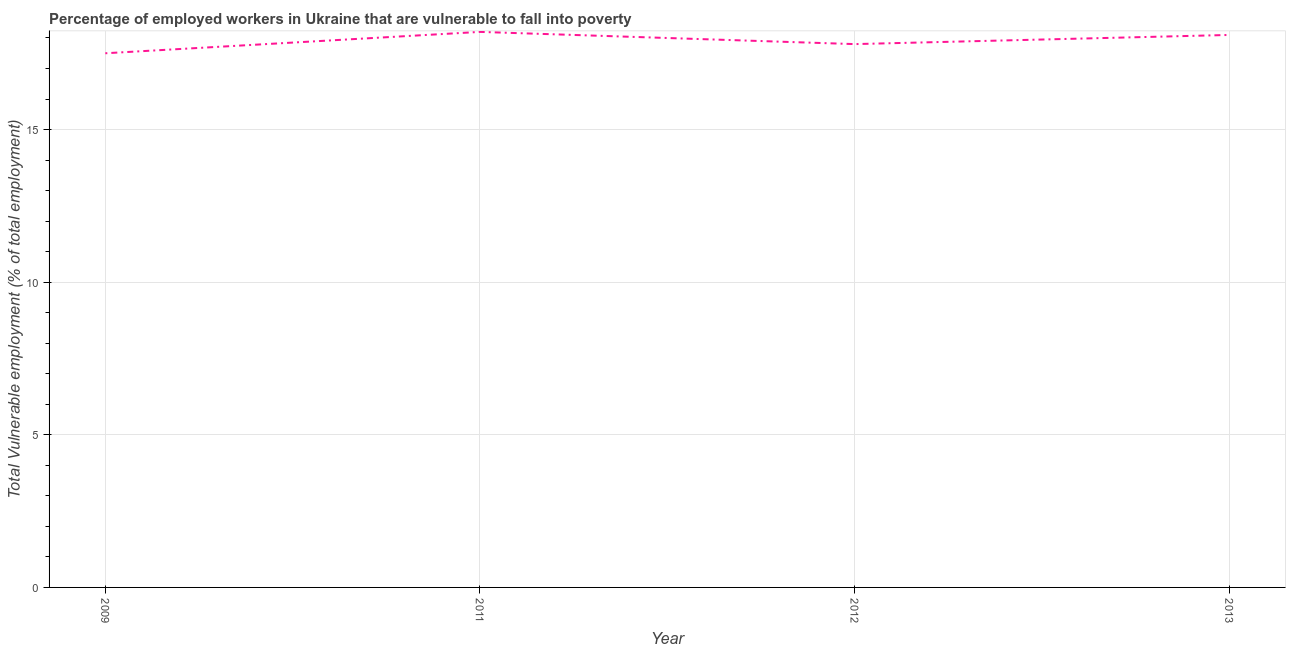What is the total vulnerable employment in 2011?
Keep it short and to the point. 18.2. Across all years, what is the maximum total vulnerable employment?
Your answer should be very brief. 18.2. Across all years, what is the minimum total vulnerable employment?
Your response must be concise. 17.5. In which year was the total vulnerable employment maximum?
Keep it short and to the point. 2011. What is the sum of the total vulnerable employment?
Give a very brief answer. 71.6. What is the difference between the total vulnerable employment in 2012 and 2013?
Ensure brevity in your answer.  -0.3. What is the average total vulnerable employment per year?
Give a very brief answer. 17.9. What is the median total vulnerable employment?
Give a very brief answer. 17.95. Do a majority of the years between 2013 and 2009 (inclusive) have total vulnerable employment greater than 6 %?
Keep it short and to the point. Yes. What is the ratio of the total vulnerable employment in 2009 to that in 2011?
Provide a short and direct response. 0.96. Is the difference between the total vulnerable employment in 2009 and 2011 greater than the difference between any two years?
Your response must be concise. Yes. What is the difference between the highest and the second highest total vulnerable employment?
Offer a terse response. 0.1. What is the difference between the highest and the lowest total vulnerable employment?
Provide a succinct answer. 0.7. In how many years, is the total vulnerable employment greater than the average total vulnerable employment taken over all years?
Provide a succinct answer. 2. How many years are there in the graph?
Your answer should be very brief. 4. What is the difference between two consecutive major ticks on the Y-axis?
Provide a short and direct response. 5. Does the graph contain grids?
Keep it short and to the point. Yes. What is the title of the graph?
Provide a short and direct response. Percentage of employed workers in Ukraine that are vulnerable to fall into poverty. What is the label or title of the Y-axis?
Provide a succinct answer. Total Vulnerable employment (% of total employment). What is the Total Vulnerable employment (% of total employment) of 2009?
Offer a terse response. 17.5. What is the Total Vulnerable employment (% of total employment) in 2011?
Offer a terse response. 18.2. What is the Total Vulnerable employment (% of total employment) of 2012?
Your answer should be compact. 17.8. What is the Total Vulnerable employment (% of total employment) in 2013?
Keep it short and to the point. 18.1. What is the difference between the Total Vulnerable employment (% of total employment) in 2009 and 2013?
Ensure brevity in your answer.  -0.6. What is the difference between the Total Vulnerable employment (% of total employment) in 2011 and 2012?
Keep it short and to the point. 0.4. What is the difference between the Total Vulnerable employment (% of total employment) in 2011 and 2013?
Offer a terse response. 0.1. What is the ratio of the Total Vulnerable employment (% of total employment) in 2009 to that in 2011?
Provide a short and direct response. 0.96. What is the ratio of the Total Vulnerable employment (% of total employment) in 2009 to that in 2012?
Ensure brevity in your answer.  0.98. What is the ratio of the Total Vulnerable employment (% of total employment) in 2011 to that in 2012?
Ensure brevity in your answer.  1.02. What is the ratio of the Total Vulnerable employment (% of total employment) in 2011 to that in 2013?
Offer a very short reply. 1.01. What is the ratio of the Total Vulnerable employment (% of total employment) in 2012 to that in 2013?
Keep it short and to the point. 0.98. 